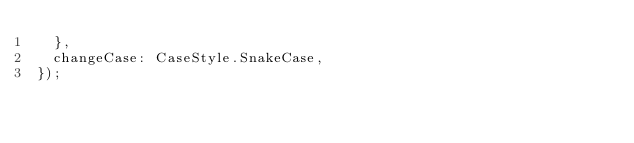Convert code to text. <code><loc_0><loc_0><loc_500><loc_500><_TypeScript_>  },
  changeCase: CaseStyle.SnakeCase,
});
</code> 